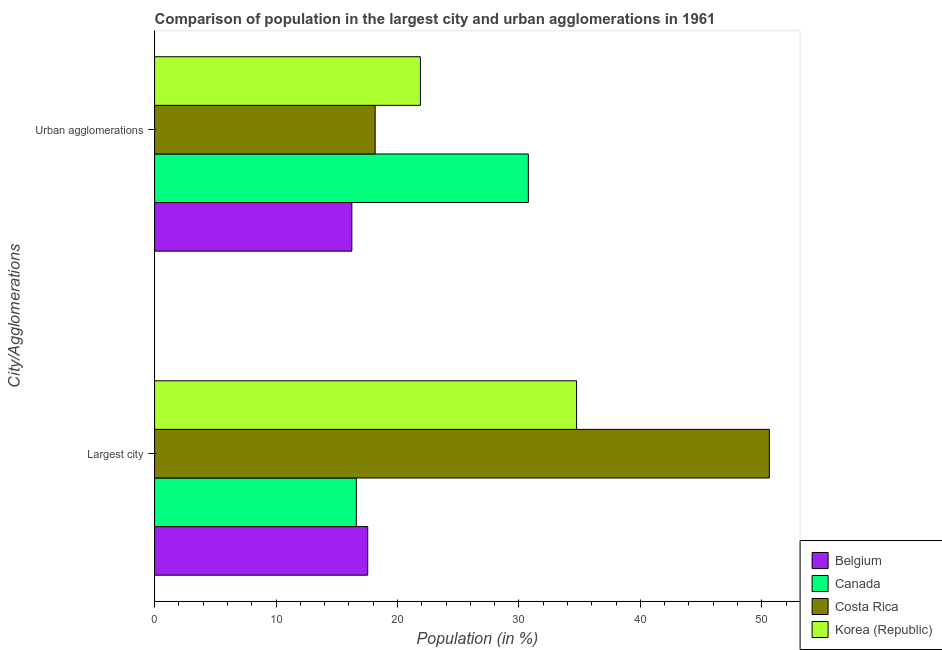How many different coloured bars are there?
Provide a succinct answer. 4. Are the number of bars per tick equal to the number of legend labels?
Give a very brief answer. Yes. Are the number of bars on each tick of the Y-axis equal?
Offer a very short reply. Yes. How many bars are there on the 2nd tick from the top?
Offer a terse response. 4. How many bars are there on the 2nd tick from the bottom?
Provide a short and direct response. 4. What is the label of the 2nd group of bars from the top?
Offer a terse response. Largest city. What is the population in urban agglomerations in Korea (Republic)?
Ensure brevity in your answer.  21.89. Across all countries, what is the maximum population in urban agglomerations?
Make the answer very short. 30.78. Across all countries, what is the minimum population in the largest city?
Ensure brevity in your answer.  16.61. In which country was the population in urban agglomerations minimum?
Your answer should be compact. Belgium. What is the total population in urban agglomerations in the graph?
Keep it short and to the point. 87.08. What is the difference between the population in the largest city in Costa Rica and that in Belgium?
Ensure brevity in your answer.  33.07. What is the difference between the population in the largest city in Korea (Republic) and the population in urban agglomerations in Costa Rica?
Provide a succinct answer. 16.59. What is the average population in the largest city per country?
Give a very brief answer. 29.88. What is the difference between the population in the largest city and population in urban agglomerations in Canada?
Your answer should be compact. -14.17. What is the ratio of the population in urban agglomerations in Belgium to that in Costa Rica?
Offer a very short reply. 0.89. How many bars are there?
Offer a very short reply. 8. How many countries are there in the graph?
Give a very brief answer. 4. Are the values on the major ticks of X-axis written in scientific E-notation?
Keep it short and to the point. No. How many legend labels are there?
Make the answer very short. 4. How are the legend labels stacked?
Your response must be concise. Vertical. What is the title of the graph?
Provide a short and direct response. Comparison of population in the largest city and urban agglomerations in 1961. Does "Brunei Darussalam" appear as one of the legend labels in the graph?
Offer a very short reply. No. What is the label or title of the X-axis?
Give a very brief answer. Population (in %). What is the label or title of the Y-axis?
Provide a short and direct response. City/Agglomerations. What is the Population (in %) in Belgium in Largest city?
Make the answer very short. 17.55. What is the Population (in %) of Canada in Largest city?
Provide a succinct answer. 16.61. What is the Population (in %) of Costa Rica in Largest city?
Make the answer very short. 50.62. What is the Population (in %) in Korea (Republic) in Largest city?
Give a very brief answer. 34.75. What is the Population (in %) of Belgium in Urban agglomerations?
Your answer should be very brief. 16.24. What is the Population (in %) in Canada in Urban agglomerations?
Keep it short and to the point. 30.78. What is the Population (in %) in Costa Rica in Urban agglomerations?
Give a very brief answer. 18.16. What is the Population (in %) in Korea (Republic) in Urban agglomerations?
Offer a very short reply. 21.89. Across all City/Agglomerations, what is the maximum Population (in %) of Belgium?
Your response must be concise. 17.55. Across all City/Agglomerations, what is the maximum Population (in %) of Canada?
Your answer should be compact. 30.78. Across all City/Agglomerations, what is the maximum Population (in %) of Costa Rica?
Offer a very short reply. 50.62. Across all City/Agglomerations, what is the maximum Population (in %) in Korea (Republic)?
Your response must be concise. 34.75. Across all City/Agglomerations, what is the minimum Population (in %) of Belgium?
Keep it short and to the point. 16.24. Across all City/Agglomerations, what is the minimum Population (in %) in Canada?
Provide a short and direct response. 16.61. Across all City/Agglomerations, what is the minimum Population (in %) in Costa Rica?
Provide a succinct answer. 18.16. Across all City/Agglomerations, what is the minimum Population (in %) in Korea (Republic)?
Make the answer very short. 21.89. What is the total Population (in %) of Belgium in the graph?
Make the answer very short. 33.8. What is the total Population (in %) of Canada in the graph?
Offer a terse response. 47.39. What is the total Population (in %) of Costa Rica in the graph?
Keep it short and to the point. 68.79. What is the total Population (in %) in Korea (Republic) in the graph?
Offer a terse response. 56.64. What is the difference between the Population (in %) in Belgium in Largest city and that in Urban agglomerations?
Provide a short and direct response. 1.31. What is the difference between the Population (in %) of Canada in Largest city and that in Urban agglomerations?
Provide a succinct answer. -14.17. What is the difference between the Population (in %) in Costa Rica in Largest city and that in Urban agglomerations?
Your answer should be very brief. 32.46. What is the difference between the Population (in %) in Korea (Republic) in Largest city and that in Urban agglomerations?
Your answer should be very brief. 12.86. What is the difference between the Population (in %) of Belgium in Largest city and the Population (in %) of Canada in Urban agglomerations?
Your answer should be very brief. -13.23. What is the difference between the Population (in %) in Belgium in Largest city and the Population (in %) in Costa Rica in Urban agglomerations?
Offer a terse response. -0.61. What is the difference between the Population (in %) of Belgium in Largest city and the Population (in %) of Korea (Republic) in Urban agglomerations?
Ensure brevity in your answer.  -4.34. What is the difference between the Population (in %) of Canada in Largest city and the Population (in %) of Costa Rica in Urban agglomerations?
Your answer should be compact. -1.55. What is the difference between the Population (in %) of Canada in Largest city and the Population (in %) of Korea (Republic) in Urban agglomerations?
Make the answer very short. -5.28. What is the difference between the Population (in %) in Costa Rica in Largest city and the Population (in %) in Korea (Republic) in Urban agglomerations?
Keep it short and to the point. 28.73. What is the average Population (in %) of Belgium per City/Agglomerations?
Provide a short and direct response. 16.9. What is the average Population (in %) of Canada per City/Agglomerations?
Your answer should be very brief. 23.69. What is the average Population (in %) of Costa Rica per City/Agglomerations?
Offer a very short reply. 34.39. What is the average Population (in %) of Korea (Republic) per City/Agglomerations?
Your answer should be very brief. 28.32. What is the difference between the Population (in %) in Belgium and Population (in %) in Canada in Largest city?
Offer a very short reply. 0.94. What is the difference between the Population (in %) in Belgium and Population (in %) in Costa Rica in Largest city?
Ensure brevity in your answer.  -33.07. What is the difference between the Population (in %) of Belgium and Population (in %) of Korea (Republic) in Largest city?
Provide a succinct answer. -17.2. What is the difference between the Population (in %) in Canada and Population (in %) in Costa Rica in Largest city?
Provide a short and direct response. -34.01. What is the difference between the Population (in %) in Canada and Population (in %) in Korea (Republic) in Largest city?
Your answer should be very brief. -18.14. What is the difference between the Population (in %) in Costa Rica and Population (in %) in Korea (Republic) in Largest city?
Keep it short and to the point. 15.87. What is the difference between the Population (in %) of Belgium and Population (in %) of Canada in Urban agglomerations?
Keep it short and to the point. -14.53. What is the difference between the Population (in %) of Belgium and Population (in %) of Costa Rica in Urban agglomerations?
Offer a terse response. -1.92. What is the difference between the Population (in %) of Belgium and Population (in %) of Korea (Republic) in Urban agglomerations?
Keep it short and to the point. -5.65. What is the difference between the Population (in %) in Canada and Population (in %) in Costa Rica in Urban agglomerations?
Give a very brief answer. 12.61. What is the difference between the Population (in %) in Canada and Population (in %) in Korea (Republic) in Urban agglomerations?
Offer a very short reply. 8.89. What is the difference between the Population (in %) of Costa Rica and Population (in %) of Korea (Republic) in Urban agglomerations?
Keep it short and to the point. -3.73. What is the ratio of the Population (in %) in Belgium in Largest city to that in Urban agglomerations?
Offer a terse response. 1.08. What is the ratio of the Population (in %) in Canada in Largest city to that in Urban agglomerations?
Give a very brief answer. 0.54. What is the ratio of the Population (in %) of Costa Rica in Largest city to that in Urban agglomerations?
Your response must be concise. 2.79. What is the ratio of the Population (in %) of Korea (Republic) in Largest city to that in Urban agglomerations?
Your answer should be compact. 1.59. What is the difference between the highest and the second highest Population (in %) of Belgium?
Your response must be concise. 1.31. What is the difference between the highest and the second highest Population (in %) of Canada?
Ensure brevity in your answer.  14.17. What is the difference between the highest and the second highest Population (in %) of Costa Rica?
Your answer should be compact. 32.46. What is the difference between the highest and the second highest Population (in %) in Korea (Republic)?
Your answer should be very brief. 12.86. What is the difference between the highest and the lowest Population (in %) in Belgium?
Make the answer very short. 1.31. What is the difference between the highest and the lowest Population (in %) in Canada?
Offer a very short reply. 14.17. What is the difference between the highest and the lowest Population (in %) in Costa Rica?
Ensure brevity in your answer.  32.46. What is the difference between the highest and the lowest Population (in %) of Korea (Republic)?
Make the answer very short. 12.86. 